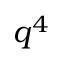<formula> <loc_0><loc_0><loc_500><loc_500>{ \boldsymbol q } ^ { 4 }</formula> 